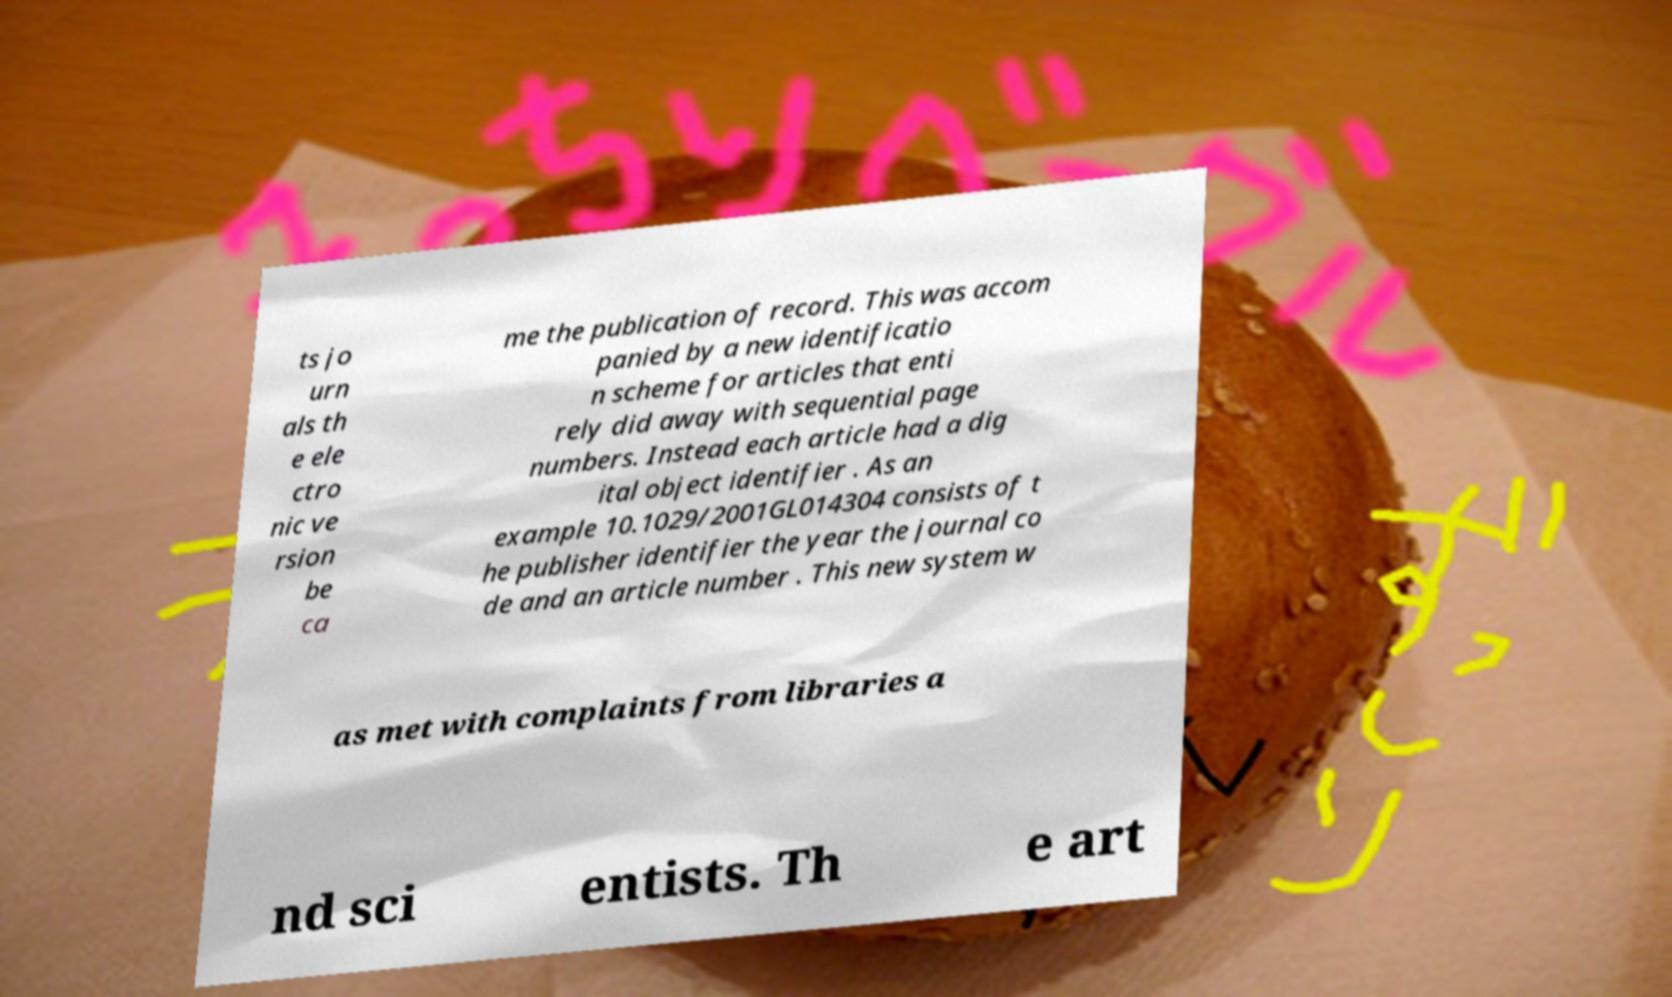Please read and relay the text visible in this image. What does it say? ts jo urn als th e ele ctro nic ve rsion be ca me the publication of record. This was accom panied by a new identificatio n scheme for articles that enti rely did away with sequential page numbers. Instead each article had a dig ital object identifier . As an example 10.1029/2001GL014304 consists of t he publisher identifier the year the journal co de and an article number . This new system w as met with complaints from libraries a nd sci entists. Th e art 